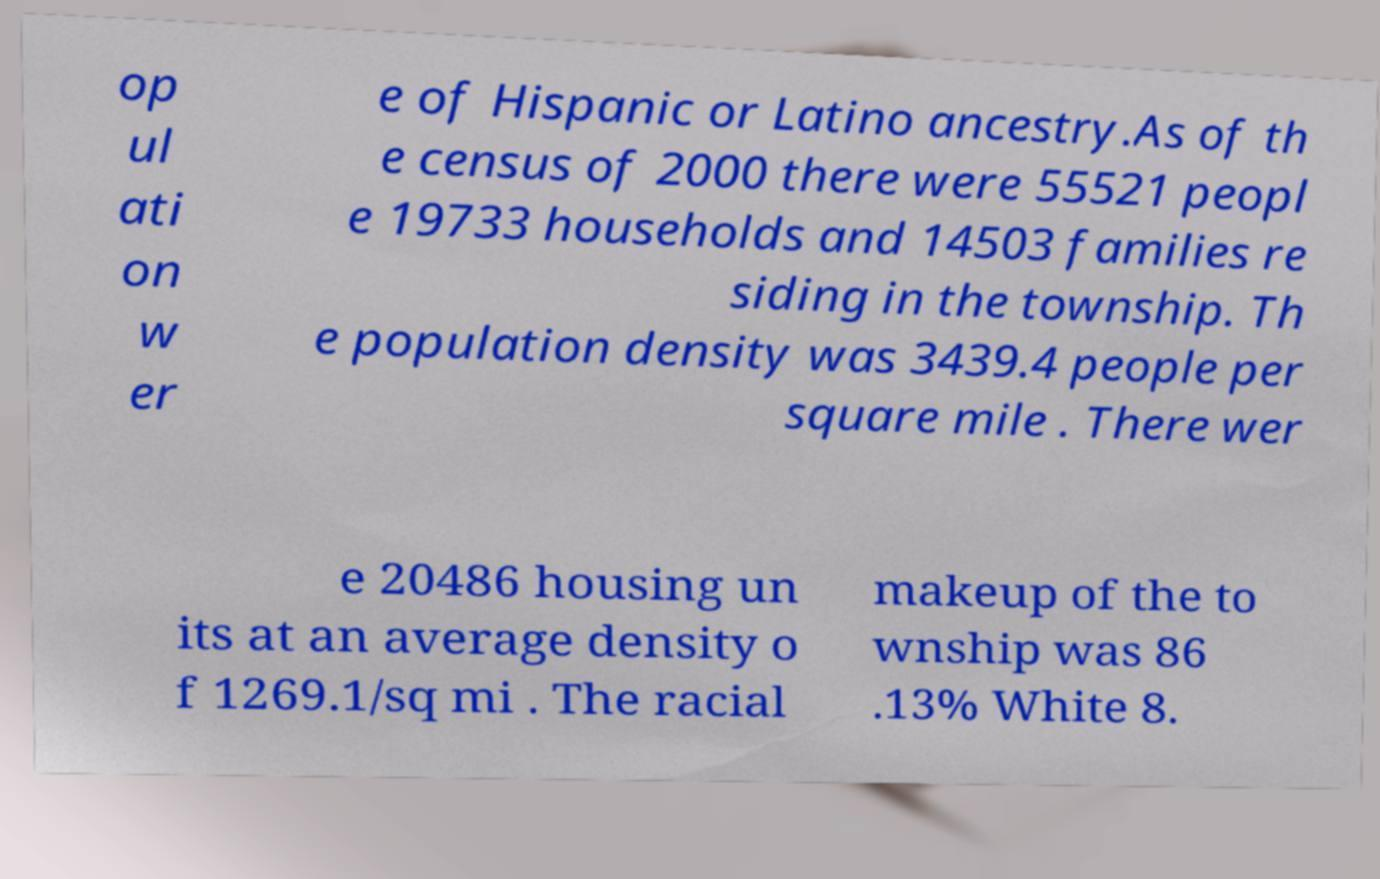Can you read and provide the text displayed in the image?This photo seems to have some interesting text. Can you extract and type it out for me? op ul ati on w er e of Hispanic or Latino ancestry.As of th e census of 2000 there were 55521 peopl e 19733 households and 14503 families re siding in the township. Th e population density was 3439.4 people per square mile . There wer e 20486 housing un its at an average density o f 1269.1/sq mi . The racial makeup of the to wnship was 86 .13% White 8. 